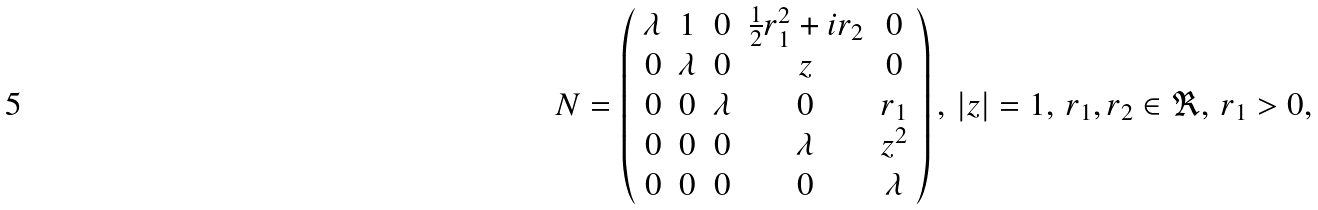<formula> <loc_0><loc_0><loc_500><loc_500>N = \left ( \begin{array} { c c c c c } \lambda & 1 & 0 & \frac { 1 } { 2 } r _ { 1 } ^ { 2 } + i r _ { 2 } & 0 \\ 0 & \lambda & 0 & z & 0 \\ 0 & 0 & \lambda & 0 & r _ { 1 } \\ 0 & 0 & 0 & \lambda & z ^ { 2 } \\ 0 & 0 & 0 & 0 & \lambda \end{array} \right ) , \, | z | = 1 , \, r _ { 1 } , r _ { 2 } \in \Re , \, r _ { 1 } > 0 ,</formula> 